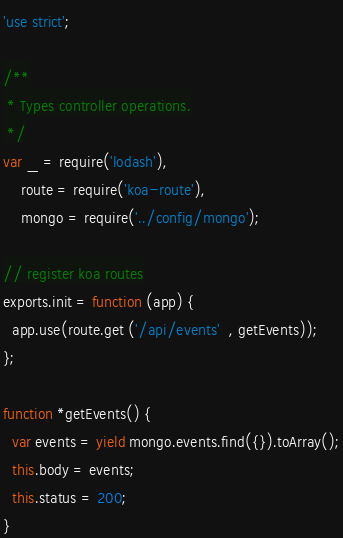<code> <loc_0><loc_0><loc_500><loc_500><_JavaScript_>'use strict';

/**
 * Types controller operations.
 */
var _ = require('lodash'),
    route = require('koa-route'),
    mongo = require('../config/mongo');

// register koa routes
exports.init = function (app) {
  app.use(route.get ('/api/events'  , getEvents));
};

function *getEvents() {
  var events = yield mongo.events.find({}).toArray();
  this.body = events;
  this.status = 200;
}
</code> 